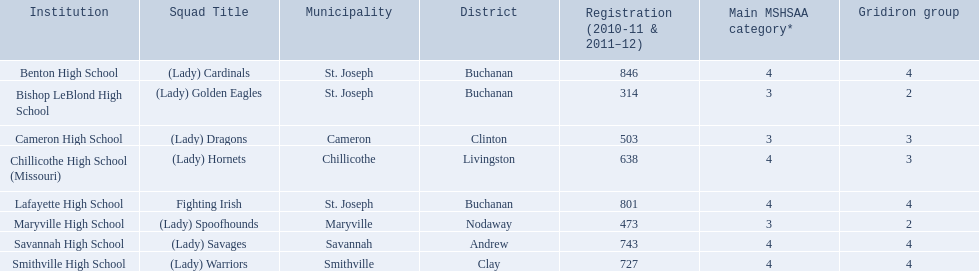What is the lowest number of students enrolled at a school as listed here? 314. What school has 314 students enrolled? Bishop LeBlond High School. 